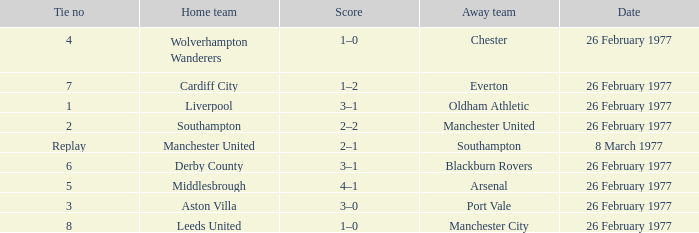What date was Chester the away team? 26 February 1977. 